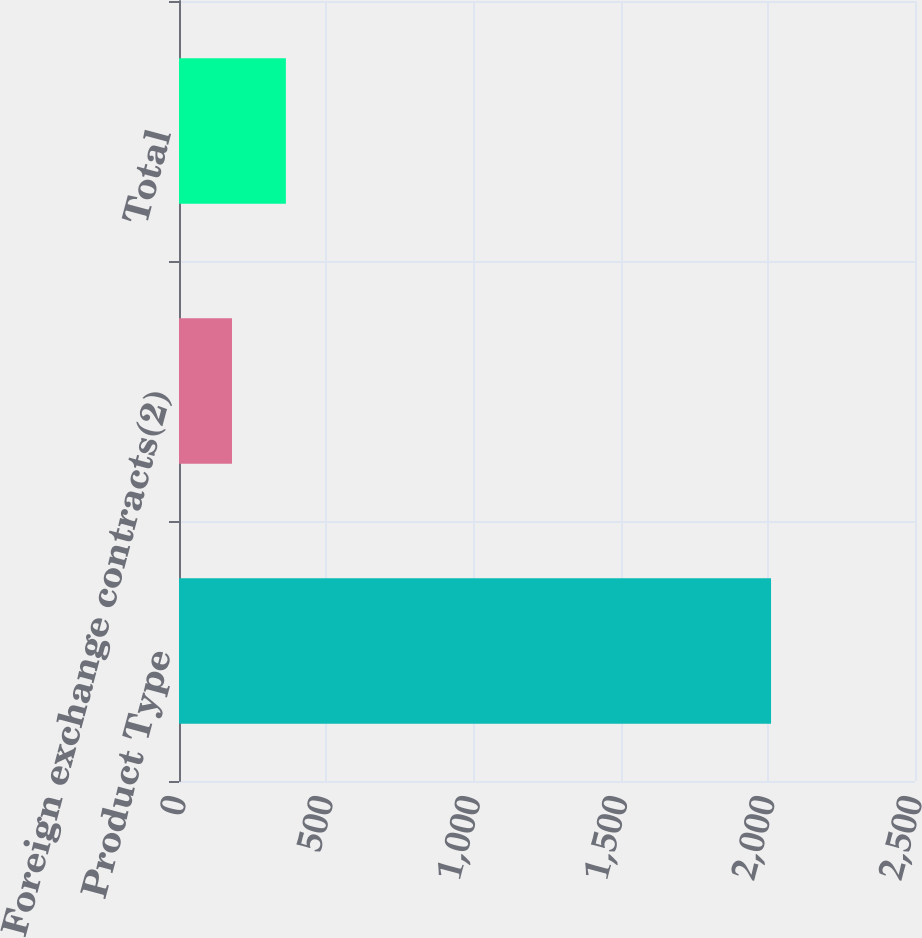<chart> <loc_0><loc_0><loc_500><loc_500><bar_chart><fcel>Product Type<fcel>Foreign exchange contracts(2)<fcel>Total<nl><fcel>2011<fcel>180<fcel>363.1<nl></chart> 